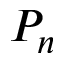Convert formula to latex. <formula><loc_0><loc_0><loc_500><loc_500>P _ { n }</formula> 